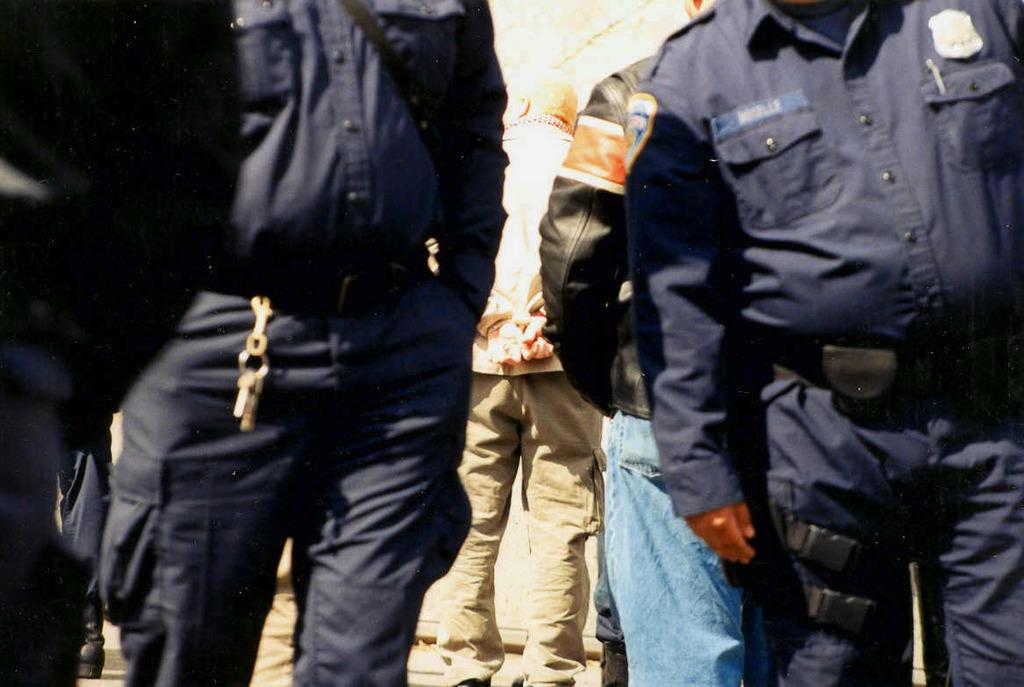Who is present in the image? There are men in the image. What are the men wearing? The men are wearing blue dresses, and one of them is wearing a black jacket. What are the men doing in the image? All of the men are standing. What type of mint is being used as a prop in the image? There is no mint present in the image. What is the men's preferred reading material in the image? There is no indication of any reading material in the image. 